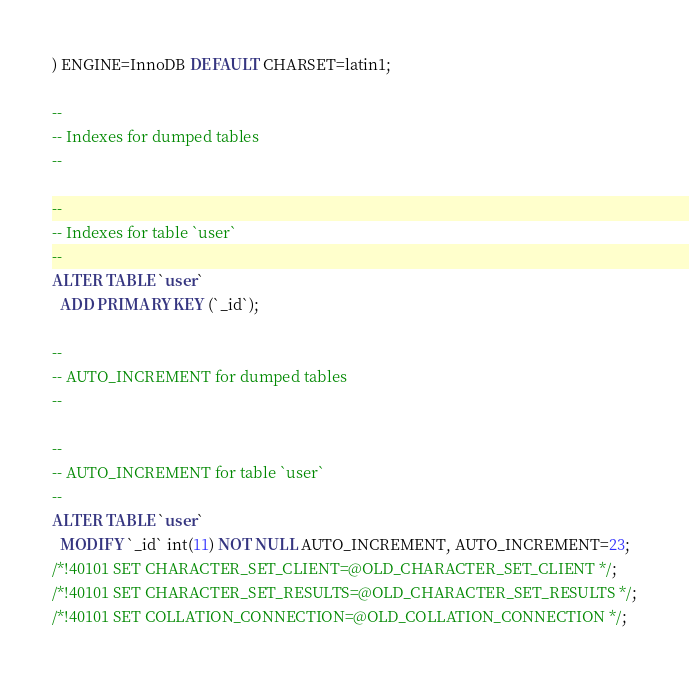Convert code to text. <code><loc_0><loc_0><loc_500><loc_500><_SQL_>) ENGINE=InnoDB DEFAULT CHARSET=latin1;

--
-- Indexes for dumped tables
--

--
-- Indexes for table `user`
--
ALTER TABLE `user`
  ADD PRIMARY KEY (`_id`);

--
-- AUTO_INCREMENT for dumped tables
--

--
-- AUTO_INCREMENT for table `user`
--
ALTER TABLE `user`
  MODIFY `_id` int(11) NOT NULL AUTO_INCREMENT, AUTO_INCREMENT=23;
/*!40101 SET CHARACTER_SET_CLIENT=@OLD_CHARACTER_SET_CLIENT */;
/*!40101 SET CHARACTER_SET_RESULTS=@OLD_CHARACTER_SET_RESULTS */;
/*!40101 SET COLLATION_CONNECTION=@OLD_COLLATION_CONNECTION */;
</code> 